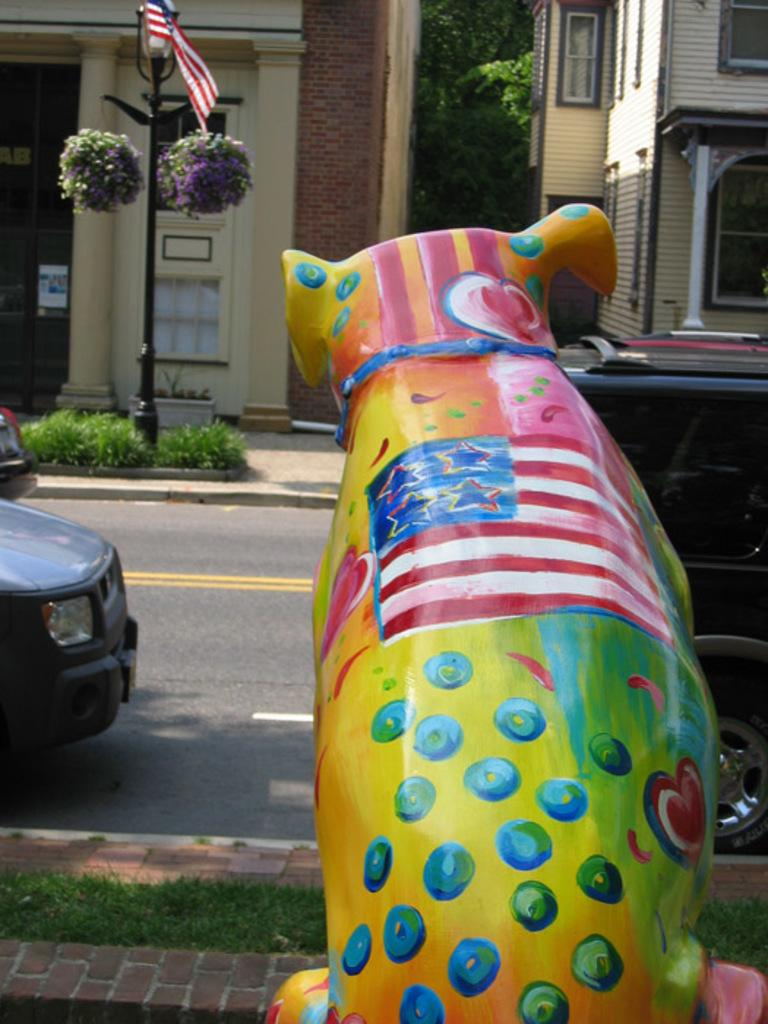What type of structures can be seen in the image? There are buildings visible in the image. What type of vehicles are present in the image? Cars are present in the image. What type of vegetation is visible in the image? There are trees visible in the image. What type of produce is being harvested in the image? There is no produce visible in the image; it features buildings, cars, and trees. What type of event is taking place in the image? There is no event taking place in the image; it simply shows buildings, cars, and trees. 